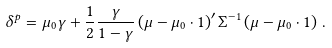Convert formula to latex. <formula><loc_0><loc_0><loc_500><loc_500>\delta ^ { p } = \mu _ { 0 } \gamma + \frac { 1 } { 2 } \frac { \gamma } { 1 - \gamma } \left ( { \mu } - \mu _ { 0 } \cdot { 1 } \right ) ^ { \prime } \Sigma ^ { - 1 } \left ( { \mu } - \mu _ { 0 } \cdot { 1 } \right ) \, .</formula> 